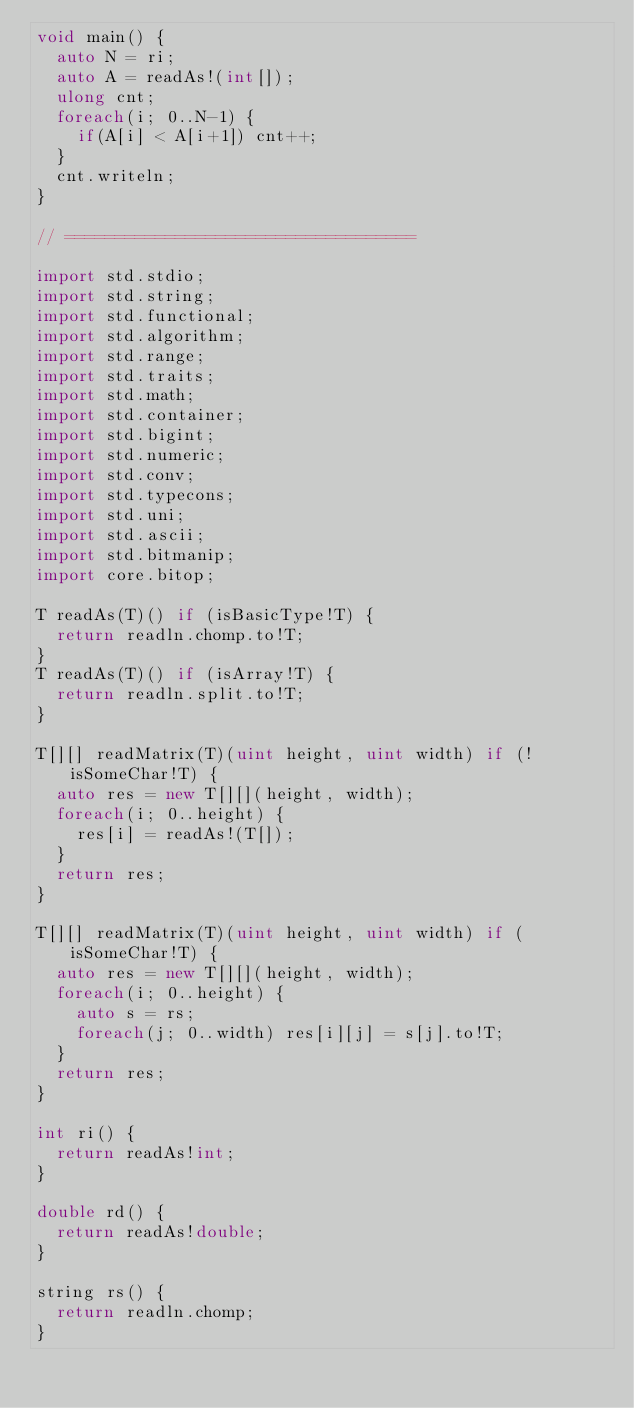<code> <loc_0><loc_0><loc_500><loc_500><_D_>void main() {
	auto N = ri;
	auto A = readAs!(int[]);
	ulong cnt;
	foreach(i; 0..N-1) {
		if(A[i] < A[i+1]) cnt++;
	}
	cnt.writeln;
}

// ===================================

import std.stdio;
import std.string;
import std.functional;
import std.algorithm;
import std.range;
import std.traits;
import std.math;
import std.container;
import std.bigint;
import std.numeric;
import std.conv;
import std.typecons;
import std.uni;
import std.ascii;
import std.bitmanip;
import core.bitop;

T readAs(T)() if (isBasicType!T) {
	return readln.chomp.to!T;
}
T readAs(T)() if (isArray!T) {
	return readln.split.to!T;
}

T[][] readMatrix(T)(uint height, uint width) if (!isSomeChar!T) {
	auto res = new T[][](height, width);
	foreach(i; 0..height) {
		res[i] = readAs!(T[]);
	}
	return res;
}

T[][] readMatrix(T)(uint height, uint width) if (isSomeChar!T) {
	auto res = new T[][](height, width);
	foreach(i; 0..height) {
		auto s = rs;
		foreach(j; 0..width) res[i][j] = s[j].to!T;
	}
	return res;
}

int ri() {
	return readAs!int;
}

double rd() {
	return readAs!double;
}

string rs() {
	return readln.chomp;
}
</code> 